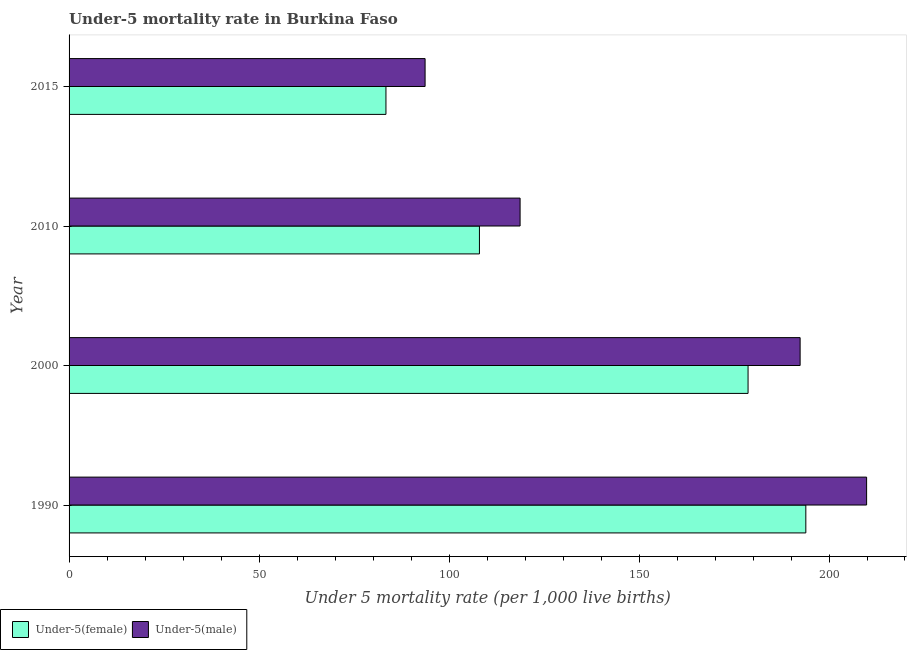How many different coloured bars are there?
Provide a succinct answer. 2. Are the number of bars on each tick of the Y-axis equal?
Provide a short and direct response. Yes. How many bars are there on the 4th tick from the bottom?
Make the answer very short. 2. What is the label of the 4th group of bars from the top?
Keep it short and to the point. 1990. In how many cases, is the number of bars for a given year not equal to the number of legend labels?
Ensure brevity in your answer.  0. What is the under-5 male mortality rate in 1990?
Provide a short and direct response. 209.9. Across all years, what is the maximum under-5 female mortality rate?
Your answer should be compact. 193.9. Across all years, what is the minimum under-5 female mortality rate?
Your answer should be compact. 83.4. In which year was the under-5 male mortality rate minimum?
Offer a terse response. 2015. What is the total under-5 male mortality rate in the graph?
Offer a very short reply. 614.7. What is the difference between the under-5 female mortality rate in 2010 and that in 2015?
Give a very brief answer. 24.6. What is the difference between the under-5 female mortality rate in 2015 and the under-5 male mortality rate in 2000?
Give a very brief answer. -109. What is the average under-5 female mortality rate per year?
Your response must be concise. 141. In how many years, is the under-5 male mortality rate greater than 40 ?
Give a very brief answer. 4. What is the ratio of the under-5 female mortality rate in 1990 to that in 2015?
Provide a succinct answer. 2.33. Is the difference between the under-5 female mortality rate in 2010 and 2015 greater than the difference between the under-5 male mortality rate in 2010 and 2015?
Your response must be concise. No. What is the difference between the highest and the second highest under-5 male mortality rate?
Your answer should be compact. 17.5. What is the difference between the highest and the lowest under-5 female mortality rate?
Offer a very short reply. 110.5. In how many years, is the under-5 female mortality rate greater than the average under-5 female mortality rate taken over all years?
Ensure brevity in your answer.  2. Is the sum of the under-5 male mortality rate in 2000 and 2010 greater than the maximum under-5 female mortality rate across all years?
Your response must be concise. Yes. What does the 2nd bar from the top in 2010 represents?
Offer a terse response. Under-5(female). What does the 2nd bar from the bottom in 2015 represents?
Provide a short and direct response. Under-5(male). Are all the bars in the graph horizontal?
Provide a short and direct response. Yes. What is the difference between two consecutive major ticks on the X-axis?
Your response must be concise. 50. Are the values on the major ticks of X-axis written in scientific E-notation?
Offer a very short reply. No. Does the graph contain any zero values?
Your answer should be very brief. No. Where does the legend appear in the graph?
Keep it short and to the point. Bottom left. What is the title of the graph?
Give a very brief answer. Under-5 mortality rate in Burkina Faso. Does "Male" appear as one of the legend labels in the graph?
Ensure brevity in your answer.  No. What is the label or title of the X-axis?
Your response must be concise. Under 5 mortality rate (per 1,0 live births). What is the Under 5 mortality rate (per 1,000 live births) in Under-5(female) in 1990?
Keep it short and to the point. 193.9. What is the Under 5 mortality rate (per 1,000 live births) of Under-5(male) in 1990?
Offer a very short reply. 209.9. What is the Under 5 mortality rate (per 1,000 live births) in Under-5(female) in 2000?
Your answer should be compact. 178.7. What is the Under 5 mortality rate (per 1,000 live births) of Under-5(male) in 2000?
Provide a succinct answer. 192.4. What is the Under 5 mortality rate (per 1,000 live births) in Under-5(female) in 2010?
Provide a succinct answer. 108. What is the Under 5 mortality rate (per 1,000 live births) in Under-5(male) in 2010?
Make the answer very short. 118.7. What is the Under 5 mortality rate (per 1,000 live births) of Under-5(female) in 2015?
Make the answer very short. 83.4. What is the Under 5 mortality rate (per 1,000 live births) in Under-5(male) in 2015?
Offer a terse response. 93.7. Across all years, what is the maximum Under 5 mortality rate (per 1,000 live births) in Under-5(female)?
Keep it short and to the point. 193.9. Across all years, what is the maximum Under 5 mortality rate (per 1,000 live births) in Under-5(male)?
Your answer should be very brief. 209.9. Across all years, what is the minimum Under 5 mortality rate (per 1,000 live births) in Under-5(female)?
Provide a succinct answer. 83.4. Across all years, what is the minimum Under 5 mortality rate (per 1,000 live births) of Under-5(male)?
Your answer should be compact. 93.7. What is the total Under 5 mortality rate (per 1,000 live births) of Under-5(female) in the graph?
Offer a terse response. 564. What is the total Under 5 mortality rate (per 1,000 live births) in Under-5(male) in the graph?
Give a very brief answer. 614.7. What is the difference between the Under 5 mortality rate (per 1,000 live births) of Under-5(female) in 1990 and that in 2000?
Offer a terse response. 15.2. What is the difference between the Under 5 mortality rate (per 1,000 live births) in Under-5(female) in 1990 and that in 2010?
Make the answer very short. 85.9. What is the difference between the Under 5 mortality rate (per 1,000 live births) of Under-5(male) in 1990 and that in 2010?
Provide a succinct answer. 91.2. What is the difference between the Under 5 mortality rate (per 1,000 live births) of Under-5(female) in 1990 and that in 2015?
Provide a short and direct response. 110.5. What is the difference between the Under 5 mortality rate (per 1,000 live births) in Under-5(male) in 1990 and that in 2015?
Give a very brief answer. 116.2. What is the difference between the Under 5 mortality rate (per 1,000 live births) of Under-5(female) in 2000 and that in 2010?
Offer a very short reply. 70.7. What is the difference between the Under 5 mortality rate (per 1,000 live births) of Under-5(male) in 2000 and that in 2010?
Your answer should be compact. 73.7. What is the difference between the Under 5 mortality rate (per 1,000 live births) of Under-5(female) in 2000 and that in 2015?
Keep it short and to the point. 95.3. What is the difference between the Under 5 mortality rate (per 1,000 live births) in Under-5(male) in 2000 and that in 2015?
Offer a terse response. 98.7. What is the difference between the Under 5 mortality rate (per 1,000 live births) of Under-5(female) in 2010 and that in 2015?
Your answer should be very brief. 24.6. What is the difference between the Under 5 mortality rate (per 1,000 live births) in Under-5(female) in 1990 and the Under 5 mortality rate (per 1,000 live births) in Under-5(male) in 2010?
Your response must be concise. 75.2. What is the difference between the Under 5 mortality rate (per 1,000 live births) in Under-5(female) in 1990 and the Under 5 mortality rate (per 1,000 live births) in Under-5(male) in 2015?
Keep it short and to the point. 100.2. What is the difference between the Under 5 mortality rate (per 1,000 live births) of Under-5(female) in 2000 and the Under 5 mortality rate (per 1,000 live births) of Under-5(male) in 2015?
Make the answer very short. 85. What is the average Under 5 mortality rate (per 1,000 live births) of Under-5(female) per year?
Offer a very short reply. 141. What is the average Under 5 mortality rate (per 1,000 live births) of Under-5(male) per year?
Offer a very short reply. 153.68. In the year 1990, what is the difference between the Under 5 mortality rate (per 1,000 live births) in Under-5(female) and Under 5 mortality rate (per 1,000 live births) in Under-5(male)?
Provide a succinct answer. -16. In the year 2000, what is the difference between the Under 5 mortality rate (per 1,000 live births) in Under-5(female) and Under 5 mortality rate (per 1,000 live births) in Under-5(male)?
Offer a very short reply. -13.7. In the year 2010, what is the difference between the Under 5 mortality rate (per 1,000 live births) of Under-5(female) and Under 5 mortality rate (per 1,000 live births) of Under-5(male)?
Provide a succinct answer. -10.7. In the year 2015, what is the difference between the Under 5 mortality rate (per 1,000 live births) of Under-5(female) and Under 5 mortality rate (per 1,000 live births) of Under-5(male)?
Give a very brief answer. -10.3. What is the ratio of the Under 5 mortality rate (per 1,000 live births) in Under-5(female) in 1990 to that in 2000?
Provide a short and direct response. 1.09. What is the ratio of the Under 5 mortality rate (per 1,000 live births) of Under-5(male) in 1990 to that in 2000?
Offer a terse response. 1.09. What is the ratio of the Under 5 mortality rate (per 1,000 live births) in Under-5(female) in 1990 to that in 2010?
Keep it short and to the point. 1.8. What is the ratio of the Under 5 mortality rate (per 1,000 live births) in Under-5(male) in 1990 to that in 2010?
Give a very brief answer. 1.77. What is the ratio of the Under 5 mortality rate (per 1,000 live births) in Under-5(female) in 1990 to that in 2015?
Offer a terse response. 2.32. What is the ratio of the Under 5 mortality rate (per 1,000 live births) of Under-5(male) in 1990 to that in 2015?
Make the answer very short. 2.24. What is the ratio of the Under 5 mortality rate (per 1,000 live births) of Under-5(female) in 2000 to that in 2010?
Your response must be concise. 1.65. What is the ratio of the Under 5 mortality rate (per 1,000 live births) of Under-5(male) in 2000 to that in 2010?
Your answer should be very brief. 1.62. What is the ratio of the Under 5 mortality rate (per 1,000 live births) in Under-5(female) in 2000 to that in 2015?
Offer a very short reply. 2.14. What is the ratio of the Under 5 mortality rate (per 1,000 live births) in Under-5(male) in 2000 to that in 2015?
Your response must be concise. 2.05. What is the ratio of the Under 5 mortality rate (per 1,000 live births) of Under-5(female) in 2010 to that in 2015?
Give a very brief answer. 1.29. What is the ratio of the Under 5 mortality rate (per 1,000 live births) in Under-5(male) in 2010 to that in 2015?
Offer a very short reply. 1.27. What is the difference between the highest and the second highest Under 5 mortality rate (per 1,000 live births) of Under-5(male)?
Provide a succinct answer. 17.5. What is the difference between the highest and the lowest Under 5 mortality rate (per 1,000 live births) in Under-5(female)?
Provide a short and direct response. 110.5. What is the difference between the highest and the lowest Under 5 mortality rate (per 1,000 live births) of Under-5(male)?
Provide a short and direct response. 116.2. 